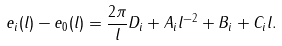Convert formula to latex. <formula><loc_0><loc_0><loc_500><loc_500>e _ { i } ( l ) - e _ { 0 } ( l ) = \frac { 2 \pi } { l } D _ { i } + A _ { i } l ^ { - 2 } + B _ { i } + C _ { i } l .</formula> 